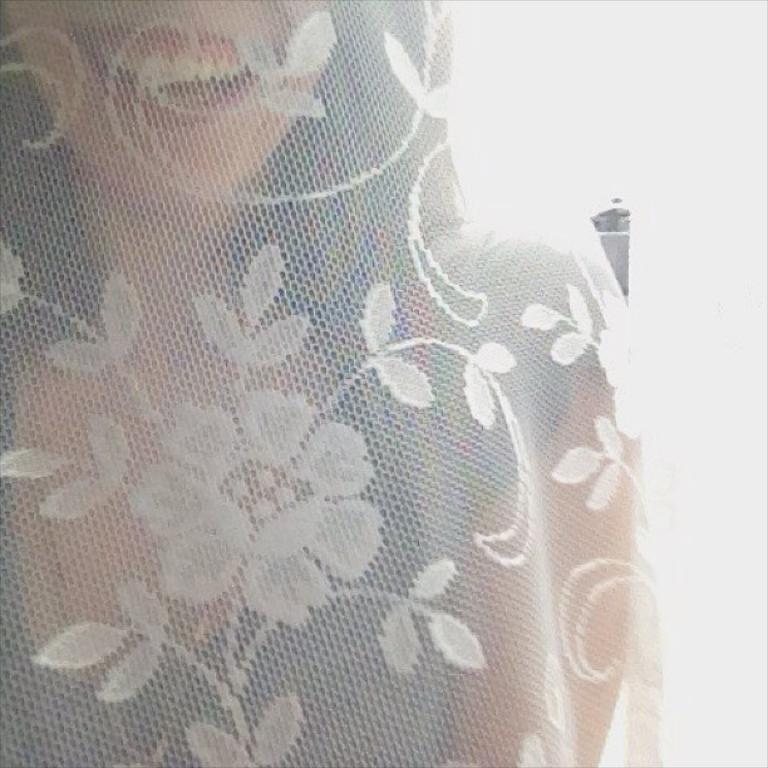Can you describe this image briefly? In this image there is a woman behind the cloth having flowers and leaves. 